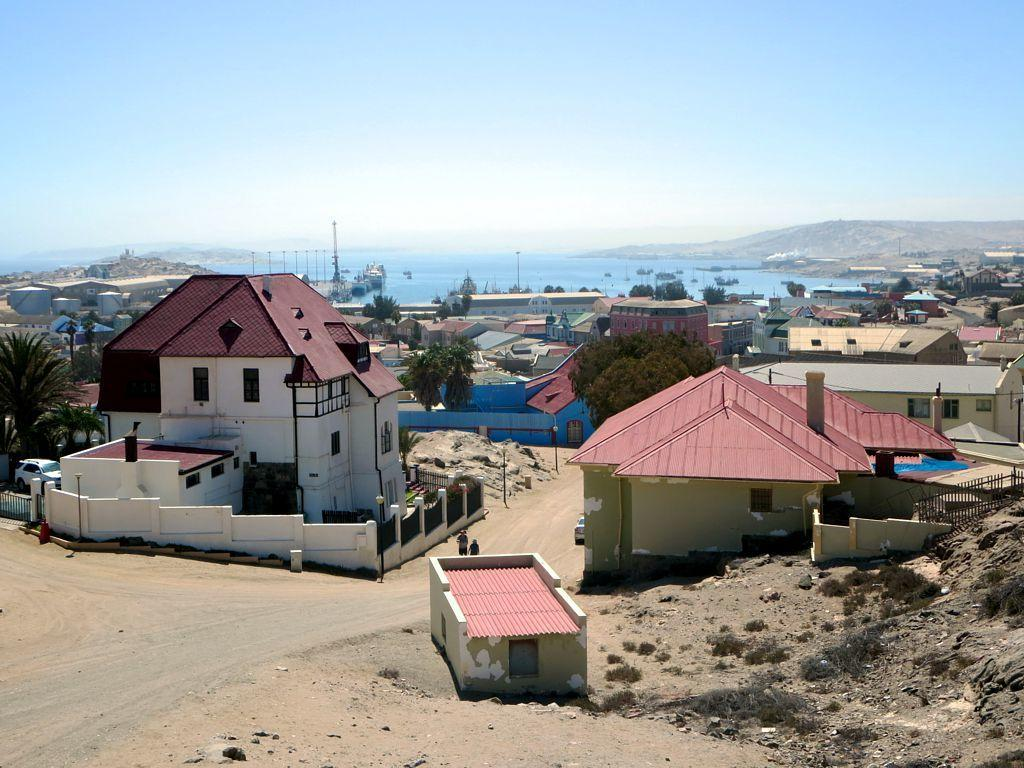What type of structures can be seen in the image? There are houses in the image. What else can be seen on the ground in the image? Some vehicles are parked on a path in the image. What is a man-made feature visible in the image? There is a wall in the image. What type of building is present in the image? There is a shed in the image. What are the tall, thin objects in the image? There are poles in the image. What type of vegetation is present in the image? There are trees in the image. What natural feature can be seen in the image? There is water visible in the image. What type of geographical feature is present in the image? There are hills in the image. What is visible above the ground in the image? The sky is visible in the image. What type of game is being played in the image? There is no game being played in the image. Is there a volcano visible in the image? No, there is no volcano present in the image. 